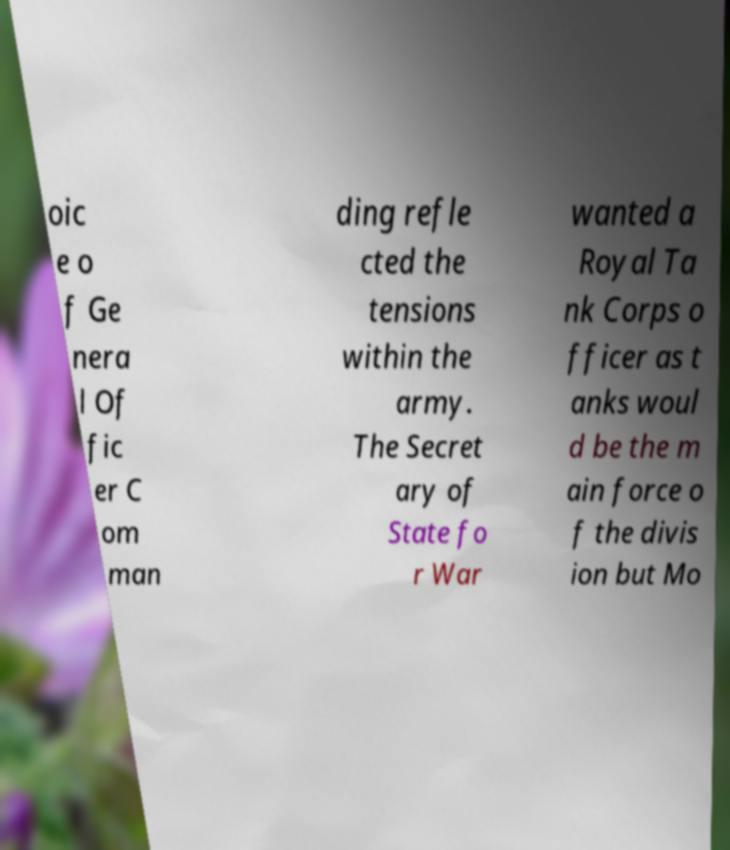I need the written content from this picture converted into text. Can you do that? oic e o f Ge nera l Of fic er C om man ding refle cted the tensions within the army. The Secret ary of State fo r War wanted a Royal Ta nk Corps o fficer as t anks woul d be the m ain force o f the divis ion but Mo 